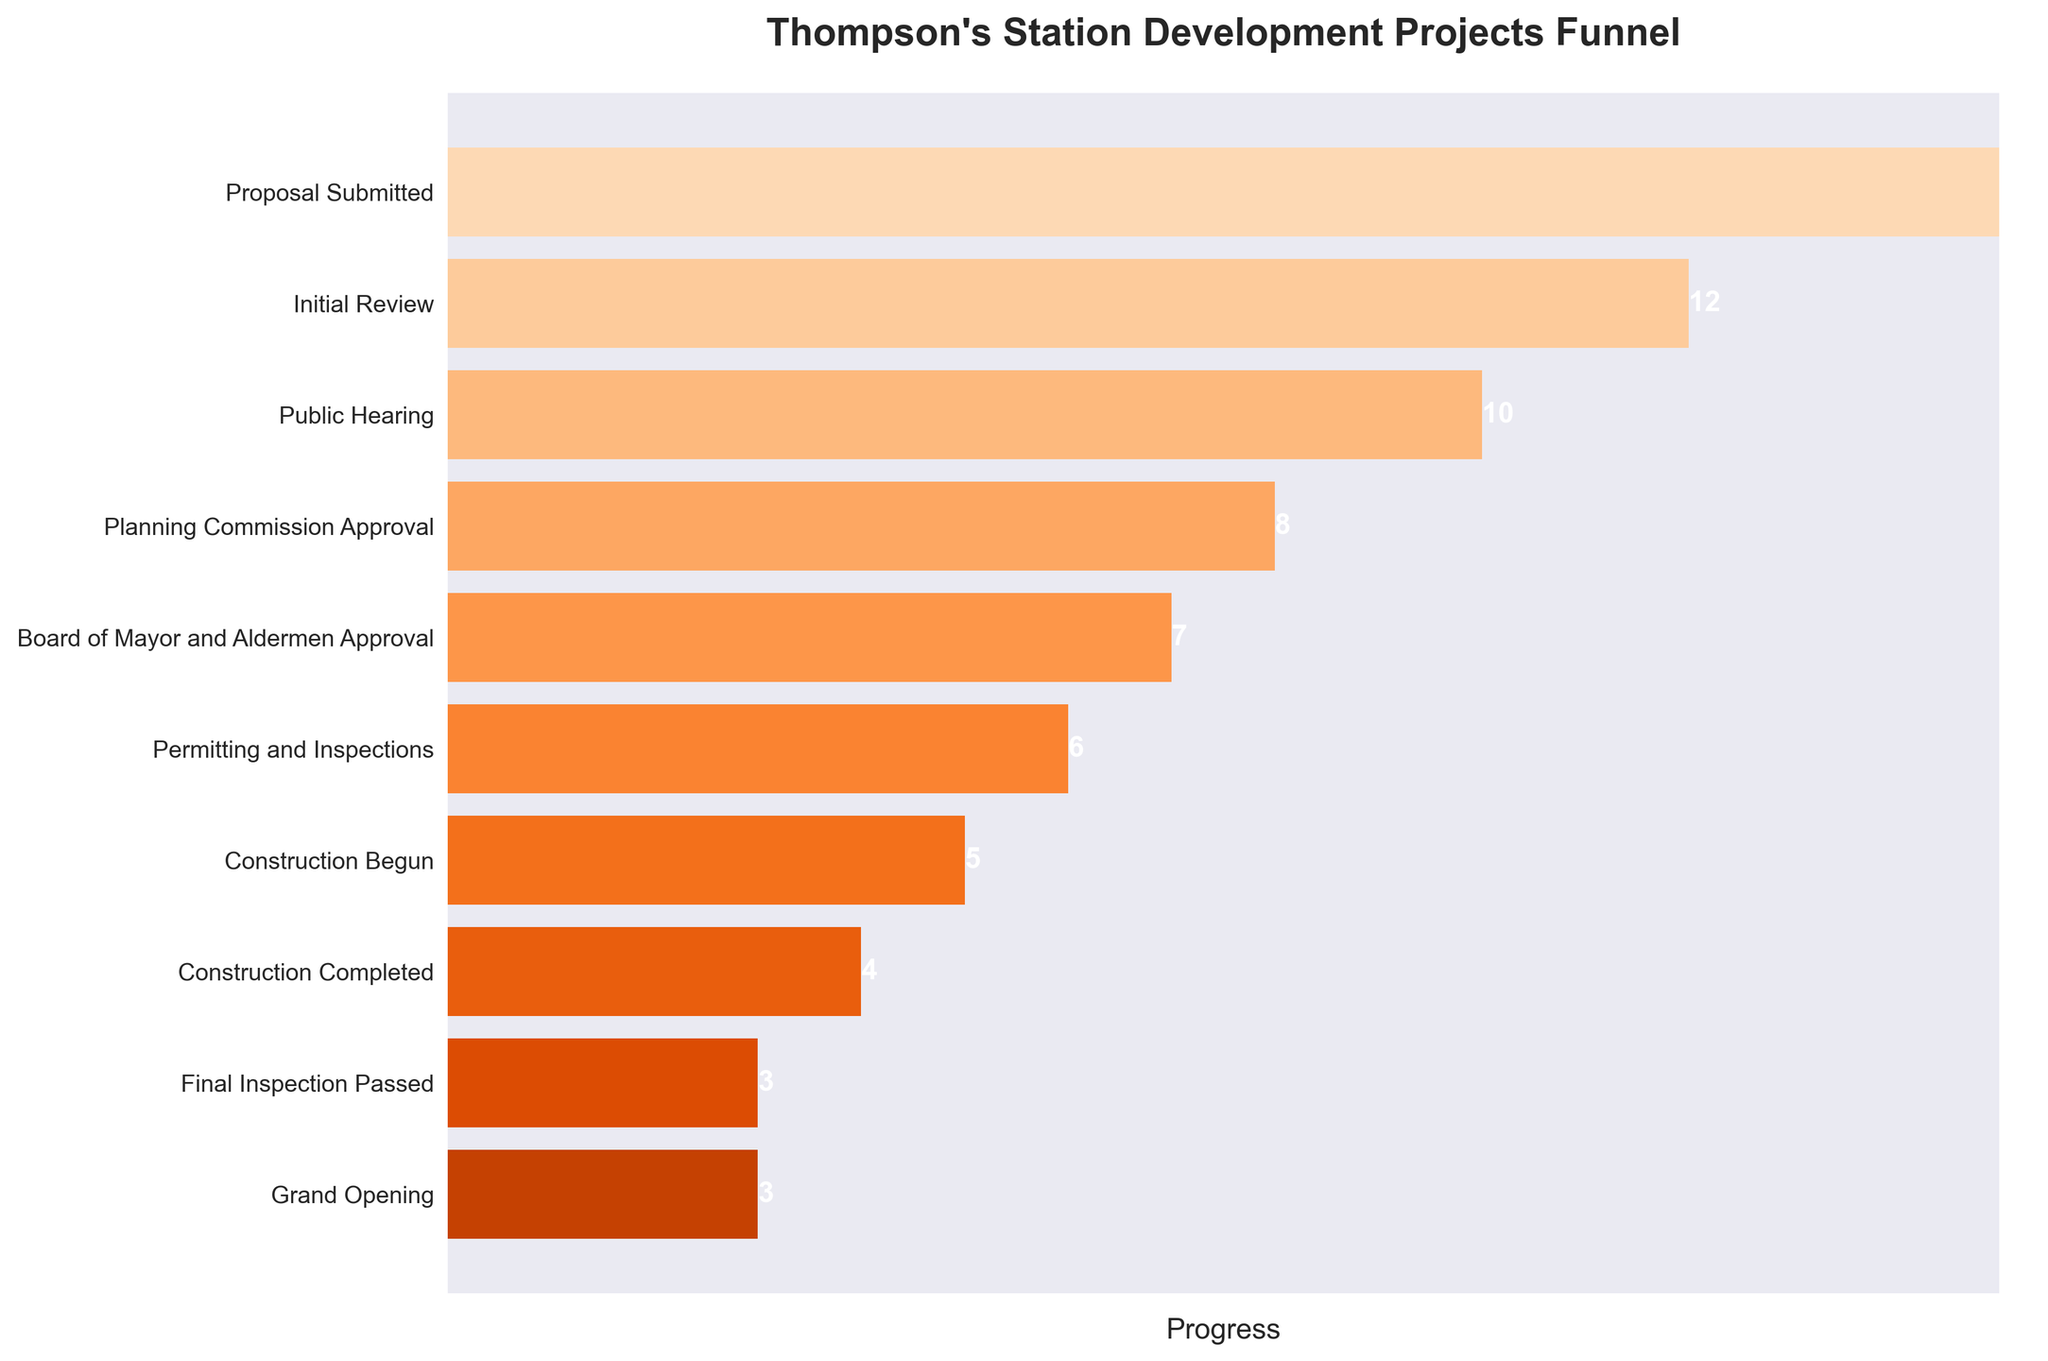How many projects have reached the "Grand Opening" stage? According to the funnel chart, we can see that the "Grand Opening" stage has a labeled value of 3 projects.
Answer: 3 How many more projects are there in the "Initial Review" stage compared to the "Planning Commission Approval" stage? The chart shows there are 12 projects in the "Initial Review" stage and 8 projects in the "Planning Commission Approval" stage. The difference is calculated as 12 - 8.
Answer: 4 What is the title of the funnel chart? The title of the funnel chart is located at the top and reads: "Thompson's Station Development Projects Funnel".
Answer: Thompson's Station Development Projects Funnel What fraction of projects have passed the "Final Inspection"? According to the chart, 3 projects have passed the "Final Inspection" out of a total of 15 at the initial "Proposal Submitted" stage. The fraction is 3/15.
Answer: 1/5 Which stage has the largest drop in the number of projects? The funnel chart shows a steep drop between the "Proposal Submitted" stage (15 projects) and the "Initial Review" stage (12 projects). The difference is 15 - 12 = 3. This is the largest drop between consecutive stages.
Answer: Proposal Submitted to Initial Review What trend is seen in the number of projects from one stage to the next? As you move down the funnel from "Proposal Submitted" to "Grand Opening", the number of projects decreases consistently. Each subsequent stage has fewer projects, indicative of a narrowing process.
Answer: Decreasing By how much does the number of projects decrease from the "Public Hearing" to the "Board of Mayor and Aldermen Approval"? The funnel chart indicates there are 10 projects at the "Public Hearing" stage and 7 projects at the "Board of Mayor and Aldermen Approval" stage. The decrease is 10 - 7.
Answer: 3 What stage represents the midpoint in this development process in terms of the number of projects? The funnel chart shows the stages visually, and the midpoint falls close to "Board of Mayor and Aldermen Approval" with 7 projects, which is approximately halfway between 15 ("Proposal Submitted") and 3 ("Grand Opening").
Answer: Board of Mayor and Aldermen Approval How many stages have fewer than 10 projects? The chart shows the number of projects for each stage, and stages with fewer than 10 projects are: "Planning Commission Approval" (8), "Board of Mayor and Aldermen Approval" (7), "Permitting and Inspections" (6), "Construction Begun" (5), "Construction Completed" (4), "Final Inspection Passed" (3), "Grand Opening" (3). There are 7 such stages.
Answer: 7 Which stage shows the highest number of projects that have been completed? All stages from "Construction Completed" onwards (i.e., "Construction Completed", "Final Inspection Passed", and "Grand Opening") show that 4 projects have been completed by the "Construction Completed" stage, which is the highest.
Answer: Construction Completed 